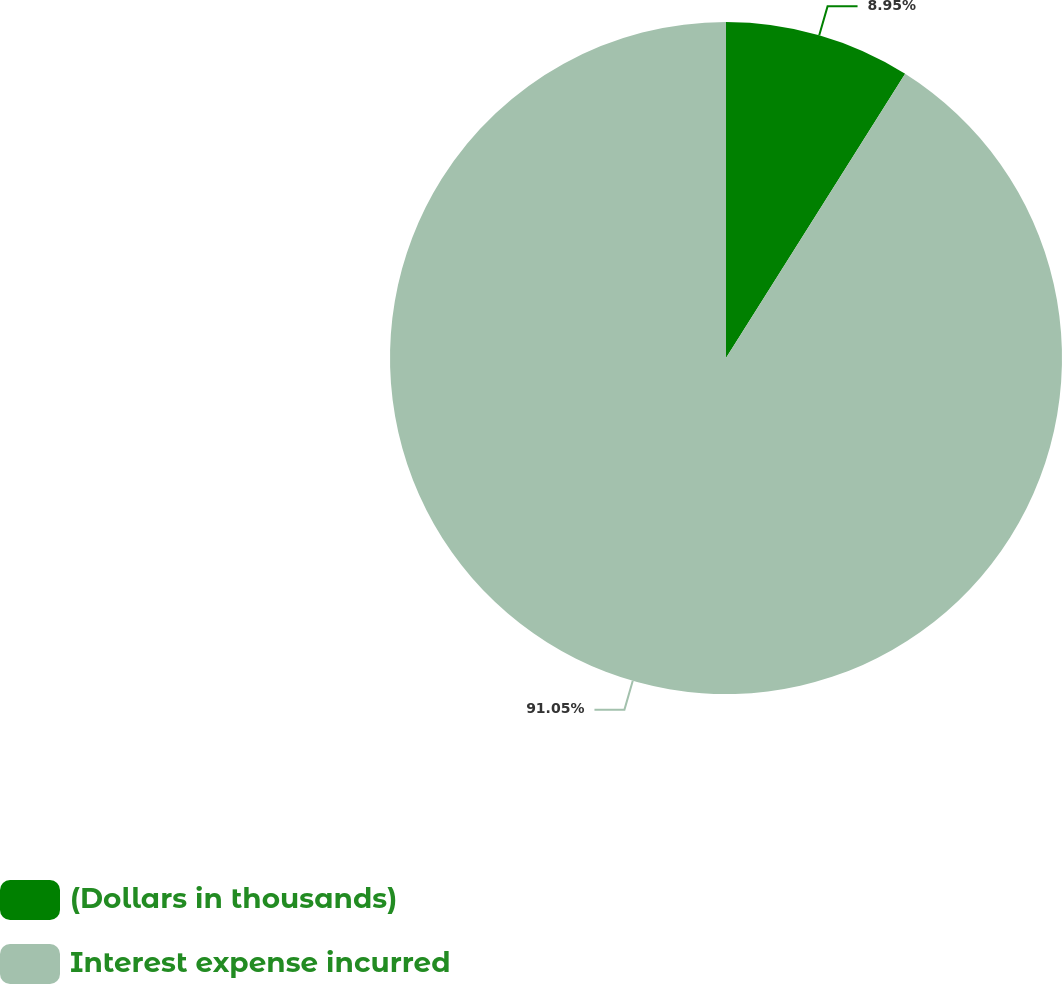Convert chart. <chart><loc_0><loc_0><loc_500><loc_500><pie_chart><fcel>(Dollars in thousands)<fcel>Interest expense incurred<nl><fcel>8.95%<fcel>91.05%<nl></chart> 